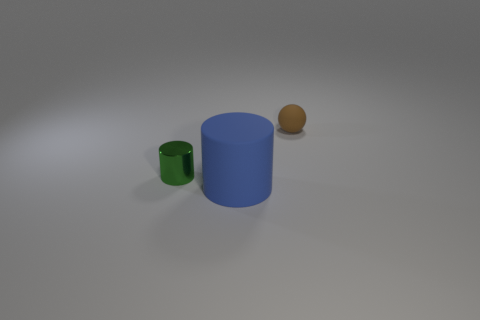Add 3 tiny green shiny cylinders. How many objects exist? 6 Subtract all cylinders. How many objects are left? 1 Subtract all yellow spheres. Subtract all blue cylinders. How many spheres are left? 1 Subtract all green metallic cylinders. Subtract all tiny rubber things. How many objects are left? 1 Add 3 matte objects. How many matte objects are left? 5 Add 1 big blue matte things. How many big blue matte things exist? 2 Subtract all blue cylinders. How many cylinders are left? 1 Subtract 0 cyan balls. How many objects are left? 3 